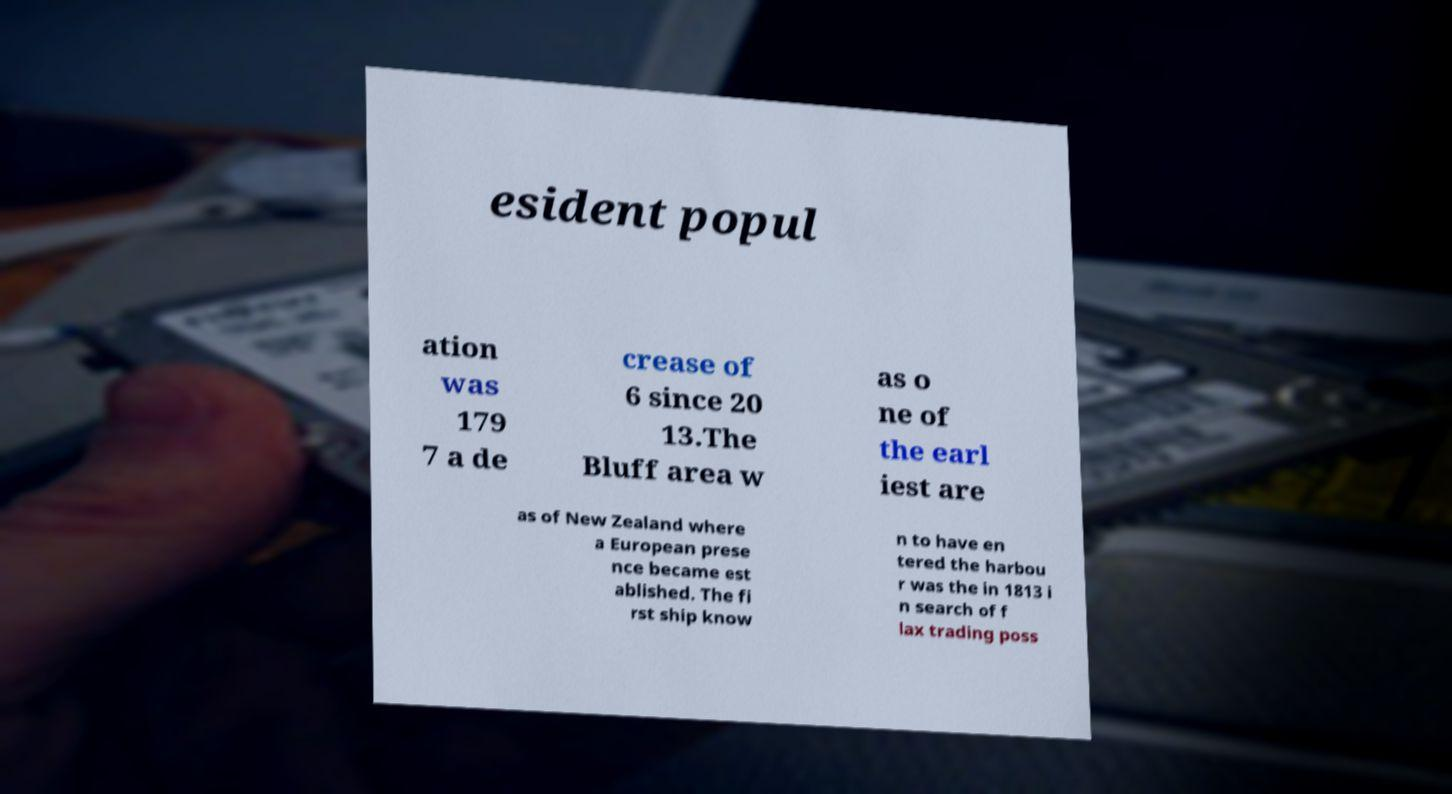I need the written content from this picture converted into text. Can you do that? esident popul ation was 179 7 a de crease of 6 since 20 13.The Bluff area w as o ne of the earl iest are as of New Zealand where a European prese nce became est ablished. The fi rst ship know n to have en tered the harbou r was the in 1813 i n search of f lax trading poss 